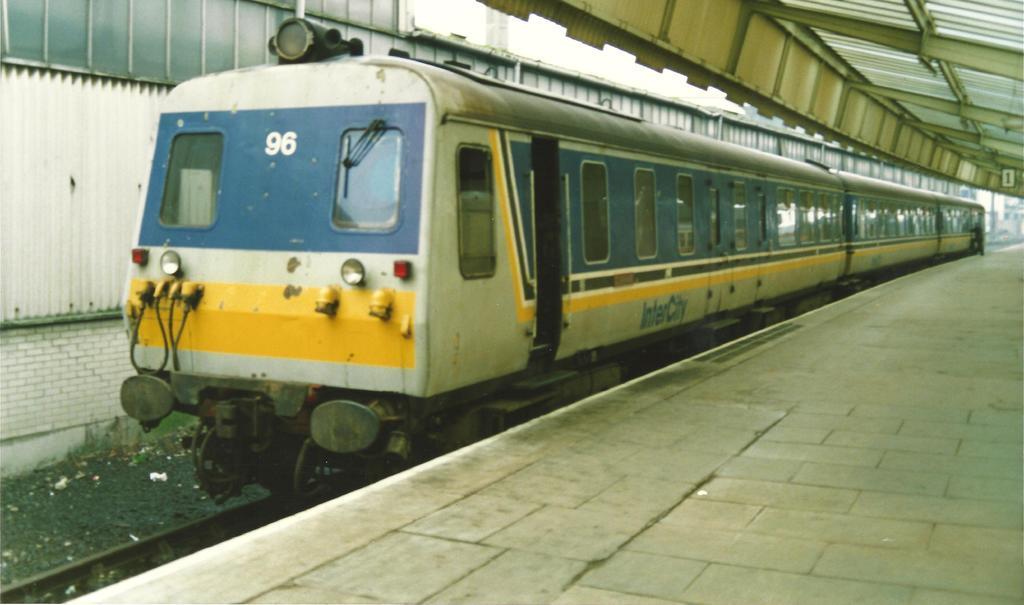Could you give a brief overview of what you see in this image? In this pic, I see a train and a platform and in the background I see a person. 